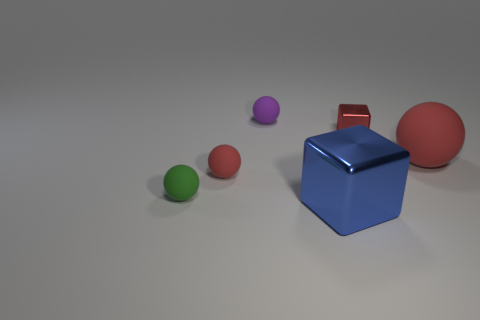Subtract all red balls. How many were subtracted if there are1red balls left? 1 Subtract 1 balls. How many balls are left? 3 Subtract all purple cubes. Subtract all green spheres. How many cubes are left? 2 Add 3 blue rubber things. How many objects exist? 9 Subtract all spheres. How many objects are left? 2 Subtract all small red shiny blocks. Subtract all blocks. How many objects are left? 3 Add 5 blue cubes. How many blue cubes are left? 6 Add 6 tiny green things. How many tiny green things exist? 7 Subtract 0 yellow balls. How many objects are left? 6 